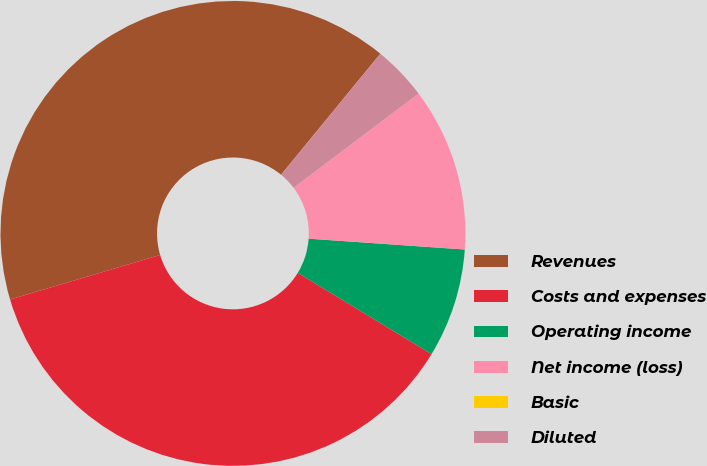Convert chart. <chart><loc_0><loc_0><loc_500><loc_500><pie_chart><fcel>Revenues<fcel>Costs and expenses<fcel>Operating income<fcel>Net income (loss)<fcel>Basic<fcel>Diluted<nl><fcel>40.52%<fcel>36.72%<fcel>7.59%<fcel>11.38%<fcel>0.0%<fcel>3.79%<nl></chart> 